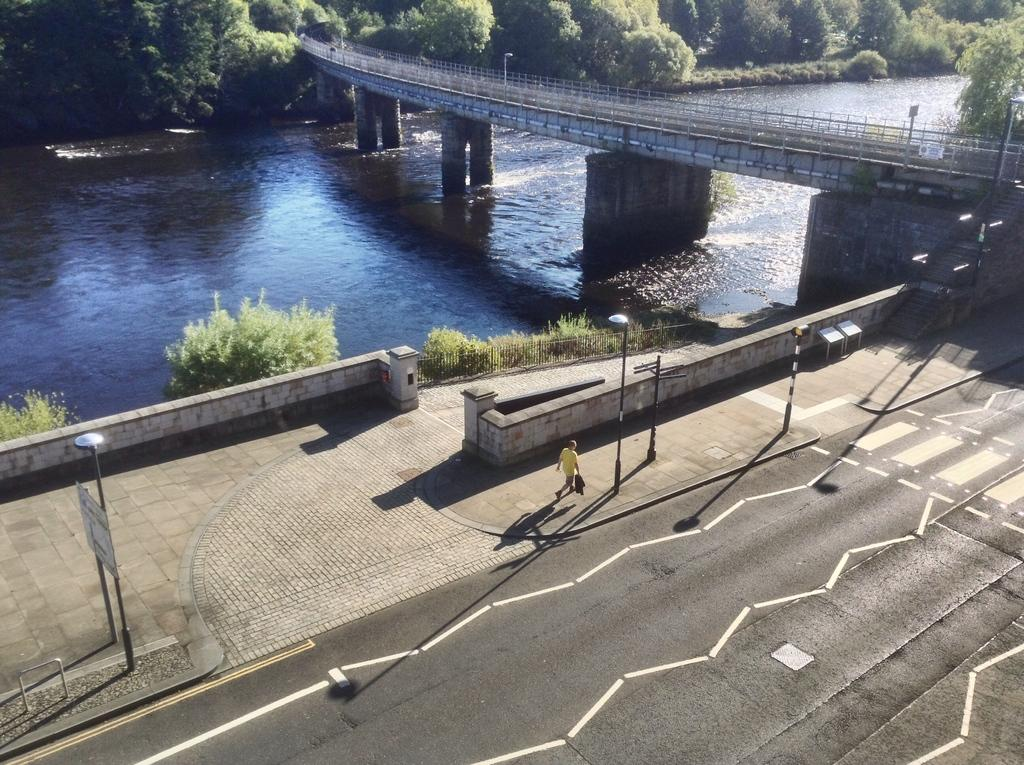What type of pathway is visible in the image? There is a road in the image. What is the person in the image doing? A person is walking on the sidewalk in the image. What structures can be seen in the image? Boards, light poles, a wall, and a fence are visible in the image. What type of vegetation is present in the image? Trees are present in the image. What can be seen in the background of the image? There is a bridge and water visible in the background of the image. How does the dust move around in the image? There is no dust present in the image; it is not mentioned in the provided facts. 